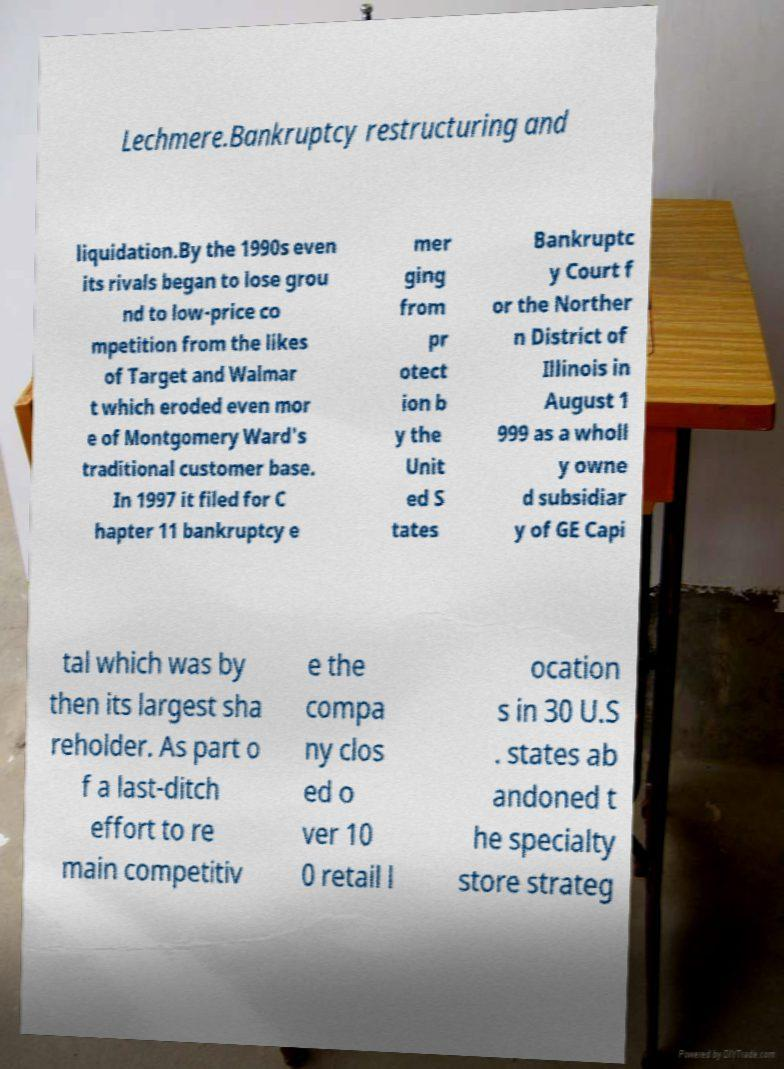Please identify and transcribe the text found in this image. Lechmere.Bankruptcy restructuring and liquidation.By the 1990s even its rivals began to lose grou nd to low-price co mpetition from the likes of Target and Walmar t which eroded even mor e of Montgomery Ward's traditional customer base. In 1997 it filed for C hapter 11 bankruptcy e mer ging from pr otect ion b y the Unit ed S tates Bankruptc y Court f or the Norther n District of Illinois in August 1 999 as a wholl y owne d subsidiar y of GE Capi tal which was by then its largest sha reholder. As part o f a last-ditch effort to re main competitiv e the compa ny clos ed o ver 10 0 retail l ocation s in 30 U.S . states ab andoned t he specialty store strateg 